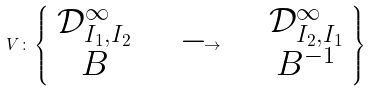<formula> <loc_0><loc_0><loc_500><loc_500>V \colon \left \{ \begin{array} c \mathcal { D } ^ { \infty } _ { I _ { 1 } , I _ { 2 } } \\ B \end{array} \quad \longrightarrow \quad \begin{array} c \mathcal { D } ^ { \infty } _ { I _ { 2 } , I _ { 1 } } \\ B ^ { - 1 } \end{array} \right \}</formula> 